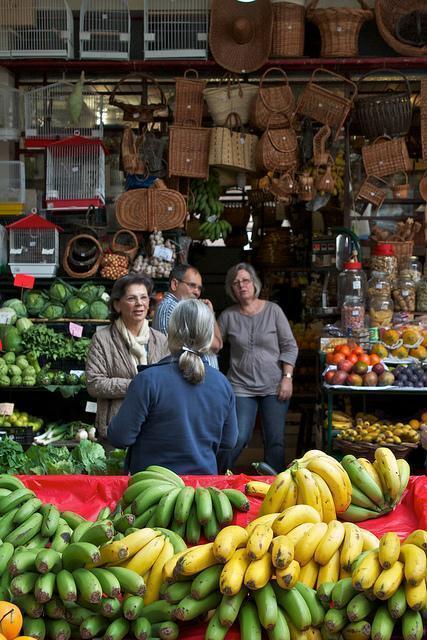What is meant to be kept in those cages?
Choose the right answer from the provided options to respond to the question.
Options: Snakes, lizards, rabbits, birds. Birds. 